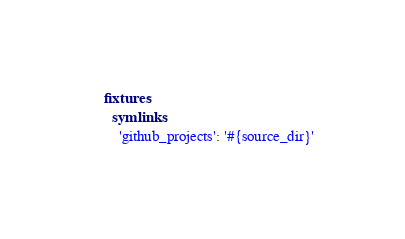<code> <loc_0><loc_0><loc_500><loc_500><_YAML_>fixtures:
  symlinks:
    'github_projects': '#{source_dir}'
</code> 